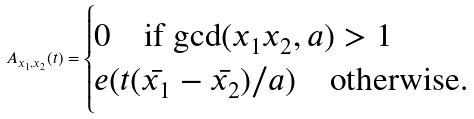<formula> <loc_0><loc_0><loc_500><loc_500>A _ { x _ { 1 } , x _ { 2 } } ( t ) = \begin{cases} 0 \quad \text {if $\gcd(x_{1} x_{2},a)>1$} \\ e ( t ( \bar { x _ { 1 } } - \bar { x _ { 2 } } ) / a ) \quad \text {otherwise.} \end{cases}</formula> 